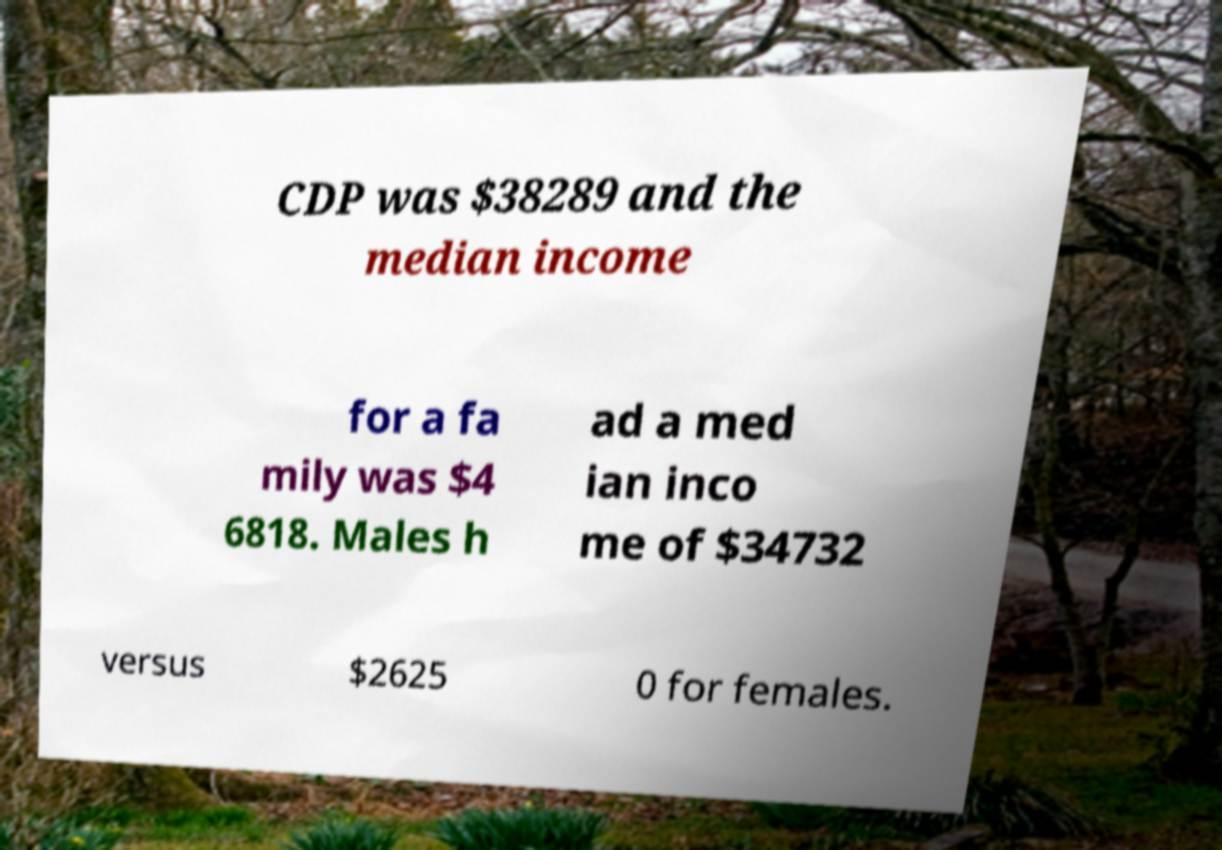Please identify and transcribe the text found in this image. CDP was $38289 and the median income for a fa mily was $4 6818. Males h ad a med ian inco me of $34732 versus $2625 0 for females. 